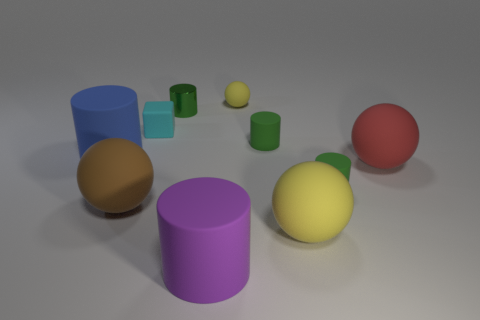There is a large ball that is the same color as the tiny ball; what is its material?
Your response must be concise. Rubber. What number of red things have the same shape as the brown thing?
Make the answer very short. 1. What size is the green cylinder that is behind the tiny thing that is to the left of the tiny green object that is to the left of the large purple cylinder?
Keep it short and to the point. Small. Does the ball that is on the left side of the purple thing have the same material as the big purple cylinder?
Make the answer very short. Yes. Are there the same number of cylinders that are in front of the big yellow rubber sphere and metal cylinders that are in front of the large brown ball?
Provide a succinct answer. No. What material is the purple object that is the same shape as the blue matte object?
Your response must be concise. Rubber. Are there any large brown spheres that are behind the yellow thing that is to the left of the small green matte cylinder behind the big blue rubber cylinder?
Ensure brevity in your answer.  No. There is a tiny matte thing that is behind the small matte cube; does it have the same shape as the yellow object in front of the cyan thing?
Offer a very short reply. Yes. Are there more large purple rubber cylinders that are behind the purple cylinder than cyan matte cylinders?
Keep it short and to the point. No. What number of things are either small yellow things or green objects?
Ensure brevity in your answer.  4. 